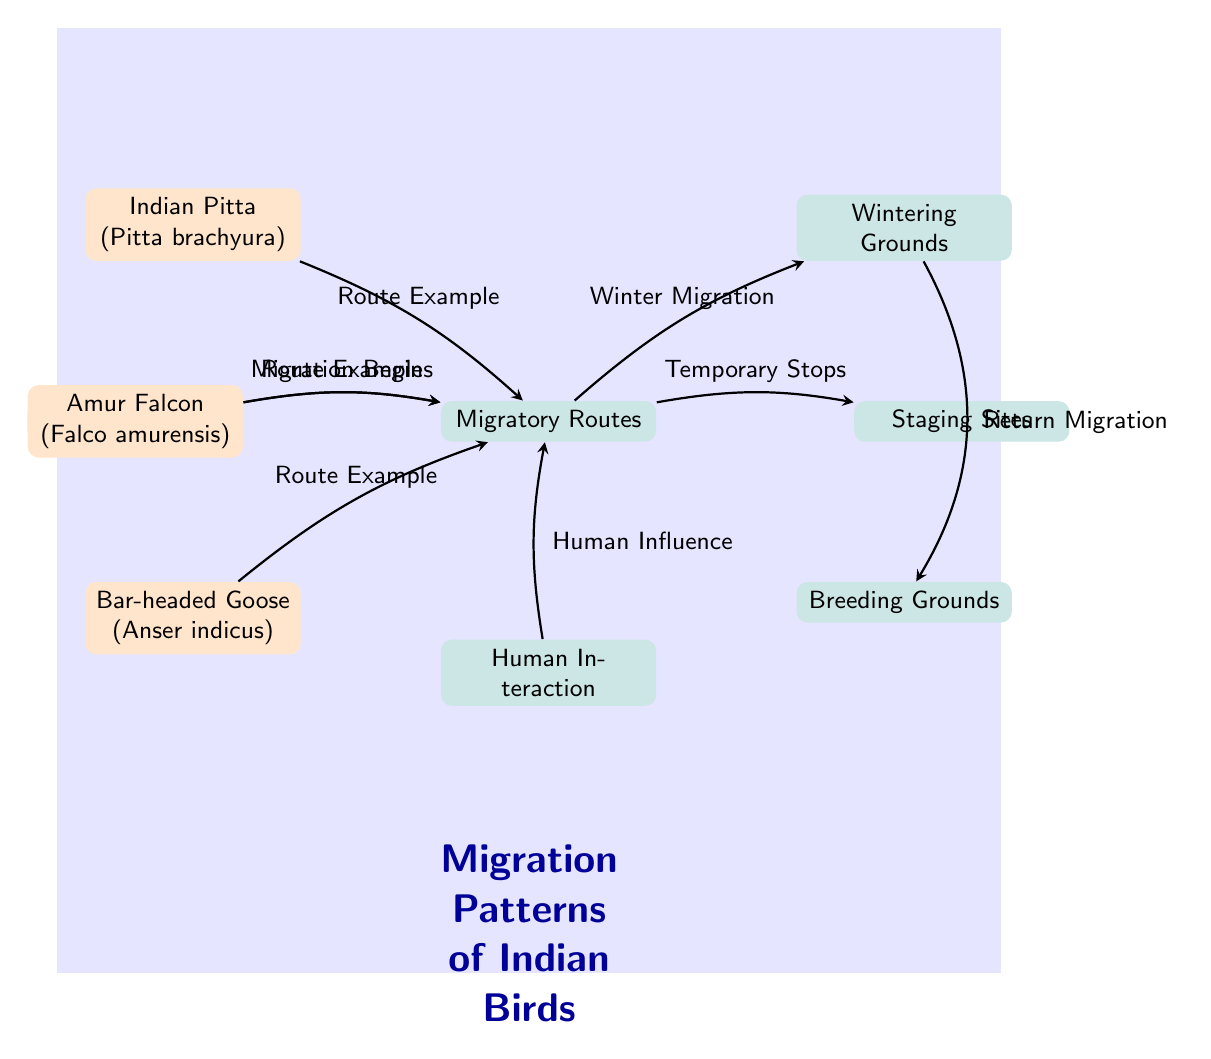What type of bird is represented by node 1? Node 1 is labeled as "Indian Pitta (Pitta brachyura)", which indicates that this node represents the Indian Pitta bird species.
Answer: Indian Pitta How many migratory routes are shown in the diagram? The diagram contains one main node labeled "Migratory Routes," which serves as the central point for different paths. There are no visually distinct routes shown; rather, the species connect to this node.
Answer: 1 What is the direction of the return migration indicated in the diagram? The diagram shows an arrow bent left from the "Wintering Grounds" to the "Breeding Grounds," indicating that the return migration goes in this direction.
Answer: Breeding Grounds What role do "Human Interaction" play in the migration patterns? The diagram illustrates that "Human Interaction" influences the "Migratory Routes," suggesting that humans affect bird migration, possibly through habitat alteration or other factors.
Answer: Human Influence Which bird species has a direct route example to the migratory routes? The diagram shows an arrow from "Amur Falcon (Falco amurensis)" directly pointing to the "Migratory Routes," indicating this bird has a route example linked to migration.
Answer: Amur Falcon What is the name of the wintering grounds in the diagram? The wintering grounds are simply labeled as "Wintering Grounds" in the diagram, clearly indicating the areas to which birds migrate during winter.
Answer: Wintering Grounds How are "Temporary Stops" related to the migratory routes? The diagram indicates that "Temporary Stops" arise directly from the "Migratory Routes," suggesting that birds take brief stops along their migration paths.
Answer: Temporary Stops Which node represents the final destination of the migration before returning? The diagram shows that "Breeding Grounds" is the final destination represented before the return migration shown by the arrow back to the breeding grounds.
Answer: Breeding Grounds How is the flow of migration initiated according to the diagram? The diagram states that migration is initiated from the node labeled "Start of Migration," which connects to "Migratory Routes," showing where the migration process begins.
Answer: Start of Migration 